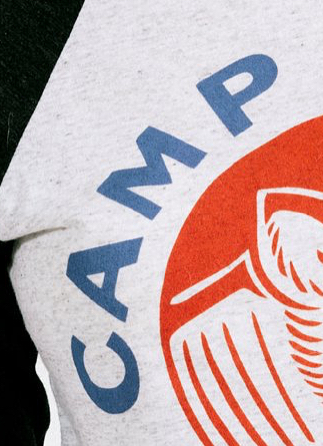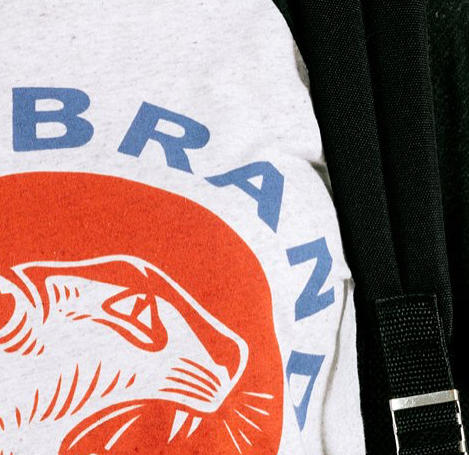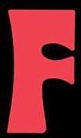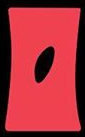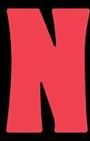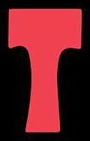What text appears in these images from left to right, separated by a semicolon? CAMP; BRAND; F; O; N; T 